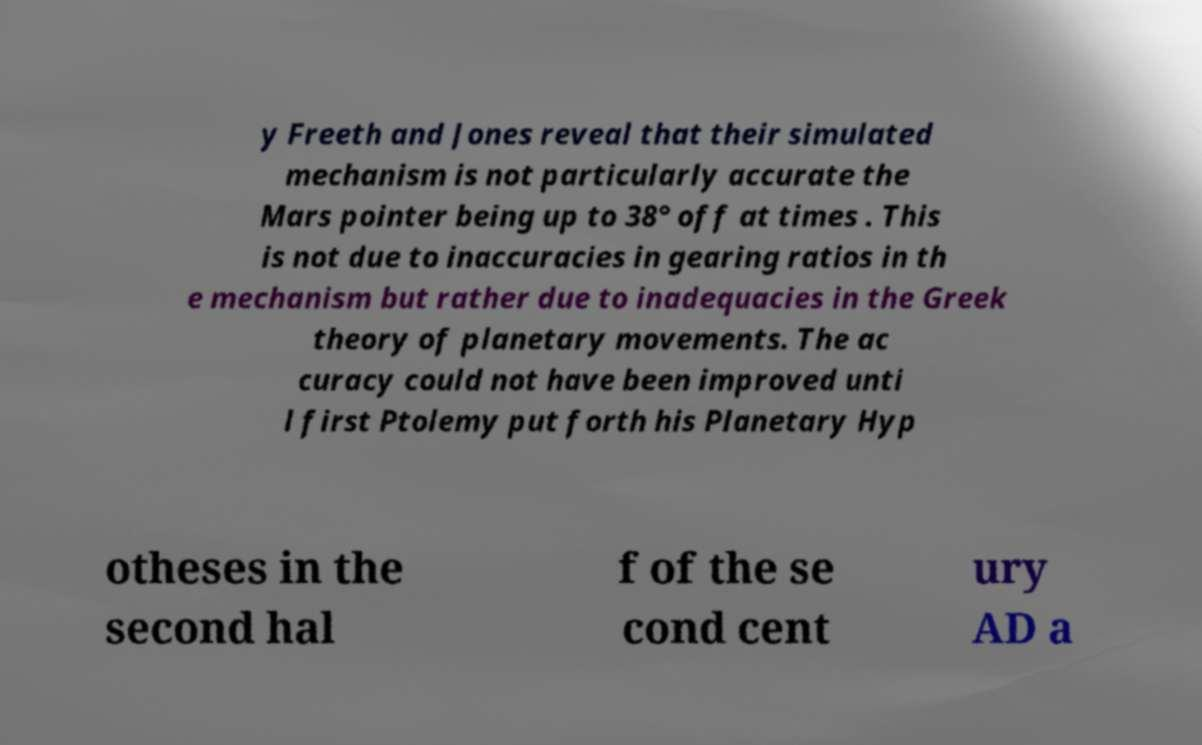For documentation purposes, I need the text within this image transcribed. Could you provide that? y Freeth and Jones reveal that their simulated mechanism is not particularly accurate the Mars pointer being up to 38° off at times . This is not due to inaccuracies in gearing ratios in th e mechanism but rather due to inadequacies in the Greek theory of planetary movements. The ac curacy could not have been improved unti l first Ptolemy put forth his Planetary Hyp otheses in the second hal f of the se cond cent ury AD a 